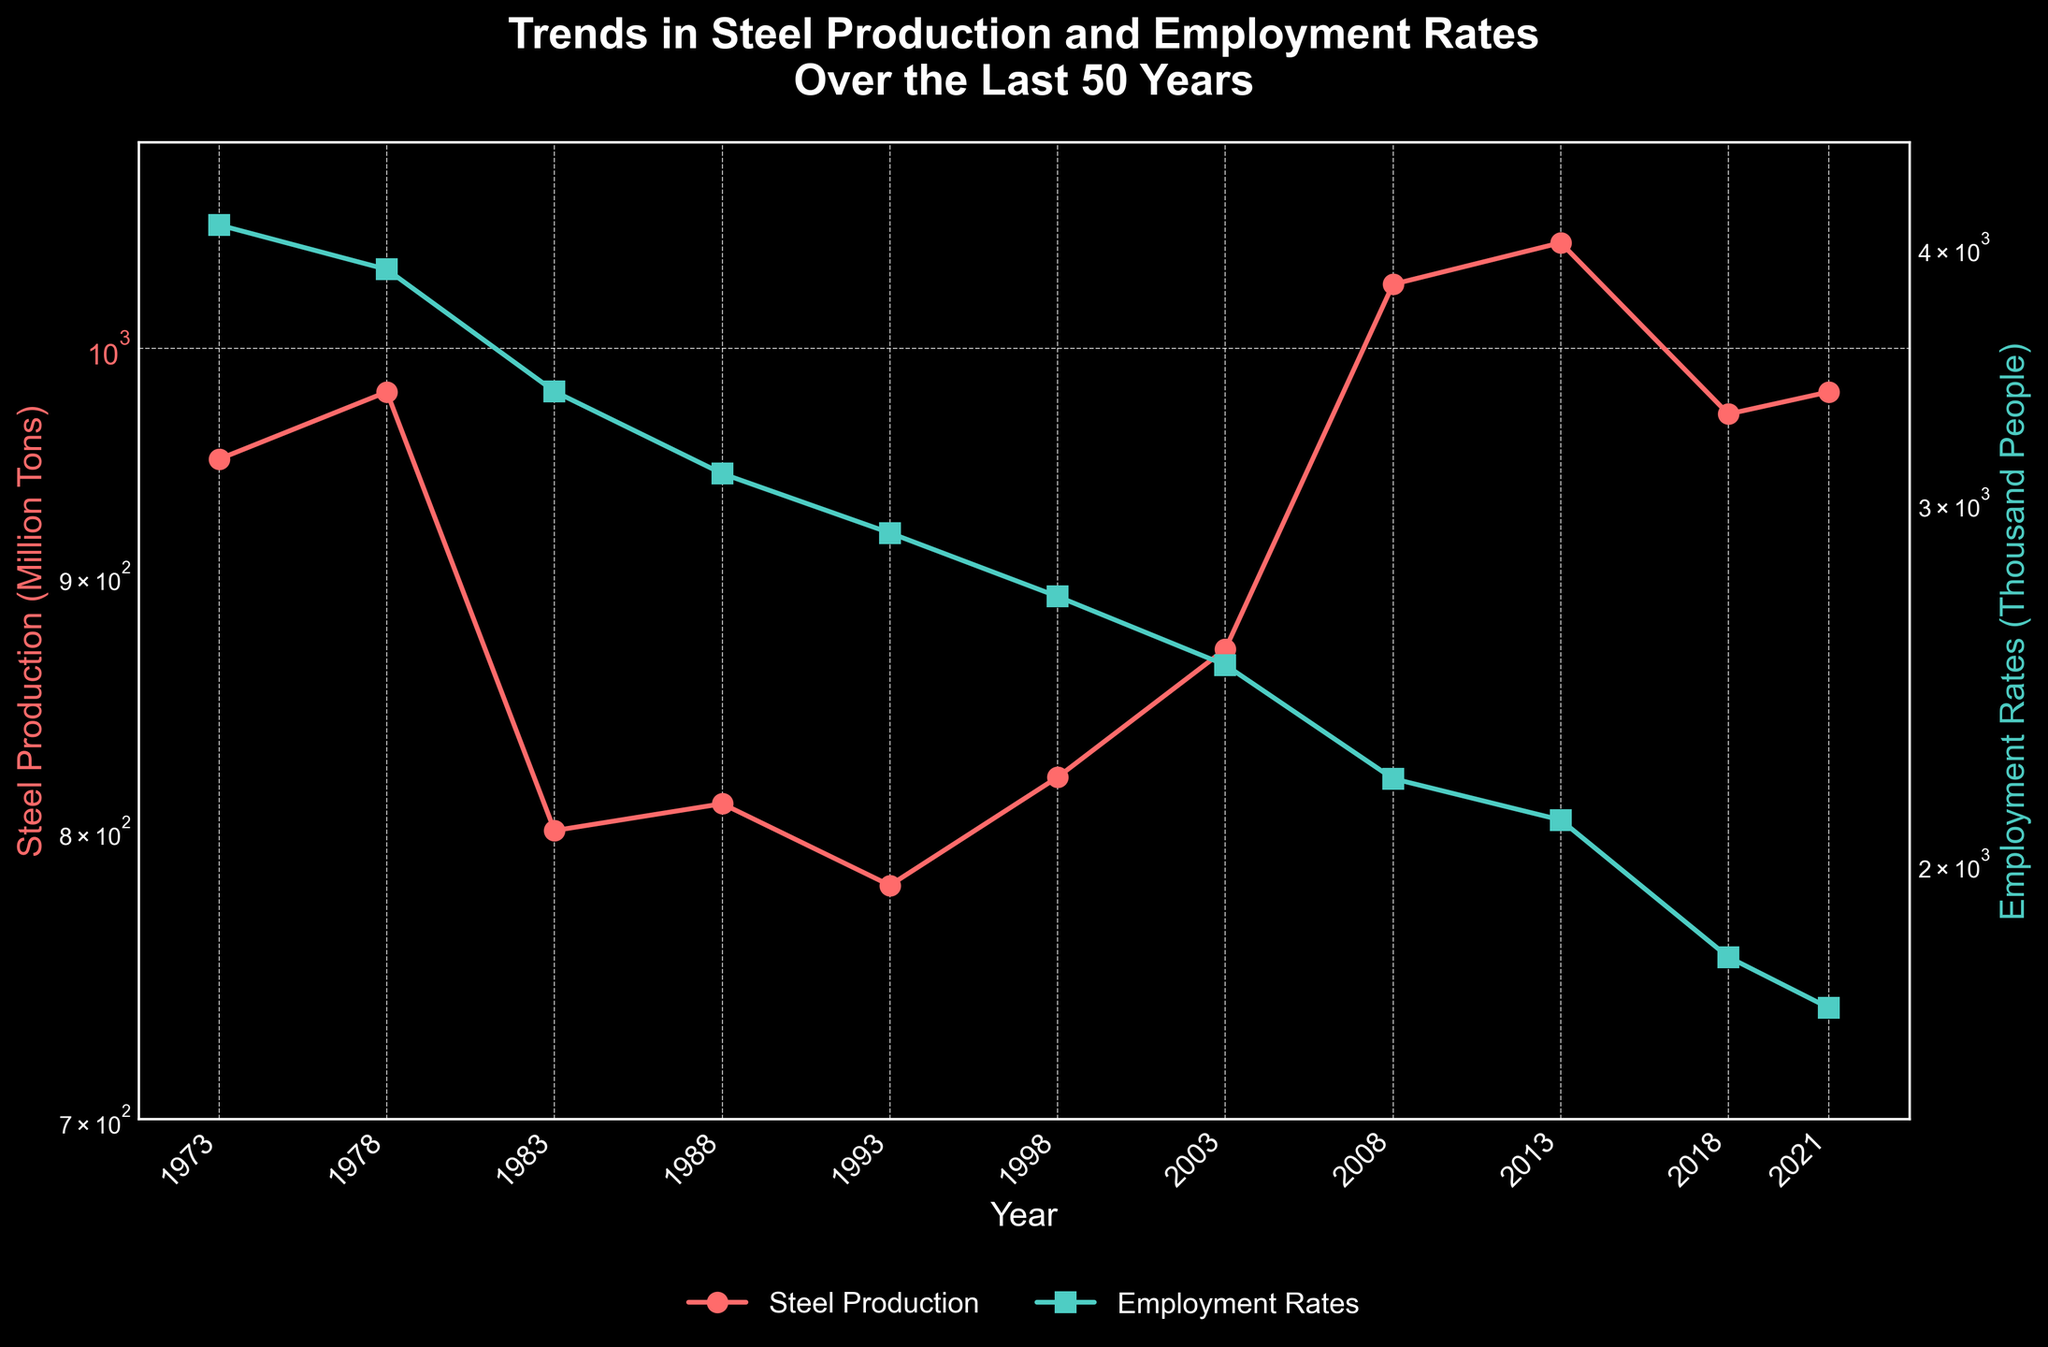What is the title of the figure? The title of the figure is located at the top and reads "Trends in Steel Production and Employment Rates Over the Last 50 Years".
Answer: Trends in Steel Production and Employment Rates Over the Last 50 Years How many years are covered in the plot? Look at the x-axis, which is labeled "Year". It ranges from 1973 to 2021, covering 11 distinct data points.
Answer: 11 years What color represents Steel Production in the plot? The color used for Steel Production is noticeable in both the line and markers, indicated by the reddish-orange hue.
Answer: reddish-orange What is the difference between Steel Production in 2013 and 2018? To get the difference, take the values for Steel Production in 2013 (1050 million tons) and in 2018 (970 million tons), then subtract the latter from the former: 1050 - 970 = 80.
Answer: 80 million tons What is the average Employment Rate from 1993 to 2003? Identify and add the Employment Rates for the years 1993 (2900), 1998 (2700), and 2003 (2500): 2900 + 2700 + 2500 = 8100. Then, divide by the number of years (3): 8100 / 3 = 2700.
Answer: 2700 thousand people Which year had higher Steel Production, 1983 or 1988? Look at the data points for both years; 1983 had 800 million tons and 1988 had 810 million tons. Compare them to see which is higher.
Answer: 1988 In which year was the Employment Rate the highest? Look at the Employment Rates for each year visually or refer to the y-axis where the green markers indicate the highest point. 1973 had the highest rate at 4100 thousand people.
Answer: 1973 How did the Steel Production trend between 1973 and 1983? Observing the plot from 1973 to 1983, the Steel Production showed a downward trend. It started at 950 million tons in 1973 and decreased to 800 million tons by 1983.
Answer: Decreased Overall, did the Employment Rates trend up or down over the last 50 years? By visually following the green line from the leftmost to the rightmost points of the plot. The Employment Rates began at 4100 thousand people in 1973 and ended with 1700 in 2021, showing a downward trend.
Answer: Down Do Steel Production and Employment Rates show a similar trend? Look at the slopes of the two lines over time. While Employment Rates steadily decline, Steel Production fluctuates but generally remains within a specific range. Hence, they do not show a similar trend.
Answer: No 